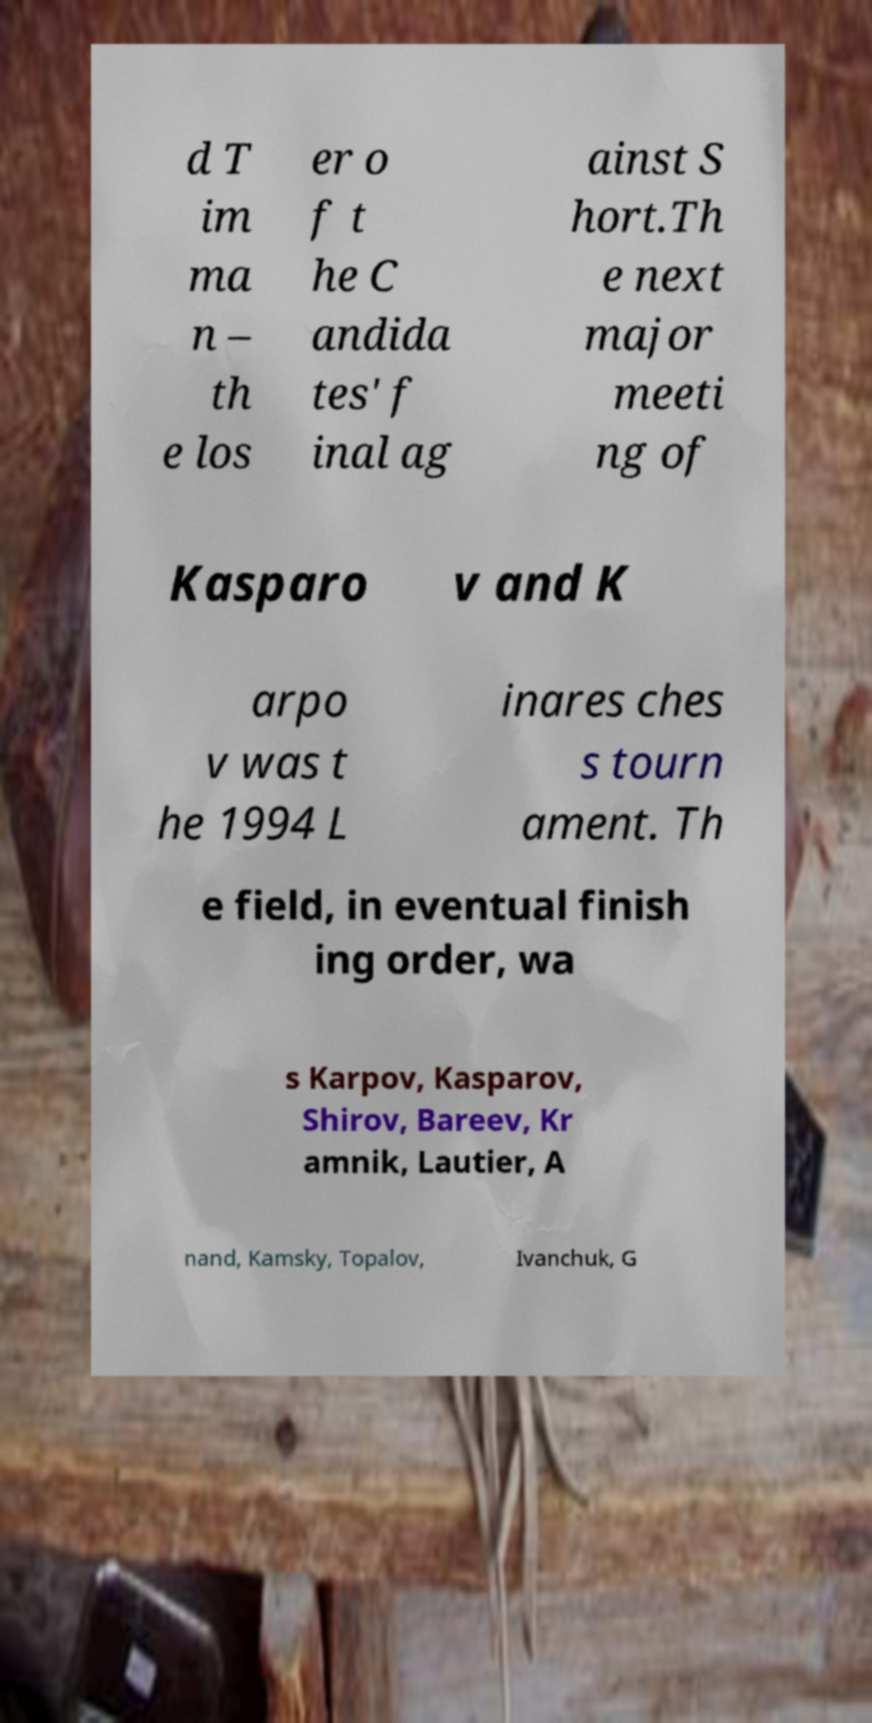Please read and relay the text visible in this image. What does it say? d T im ma n – th e los er o f t he C andida tes' f inal ag ainst S hort.Th e next major meeti ng of Kasparo v and K arpo v was t he 1994 L inares ches s tourn ament. Th e field, in eventual finish ing order, wa s Karpov, Kasparov, Shirov, Bareev, Kr amnik, Lautier, A nand, Kamsky, Topalov, Ivanchuk, G 